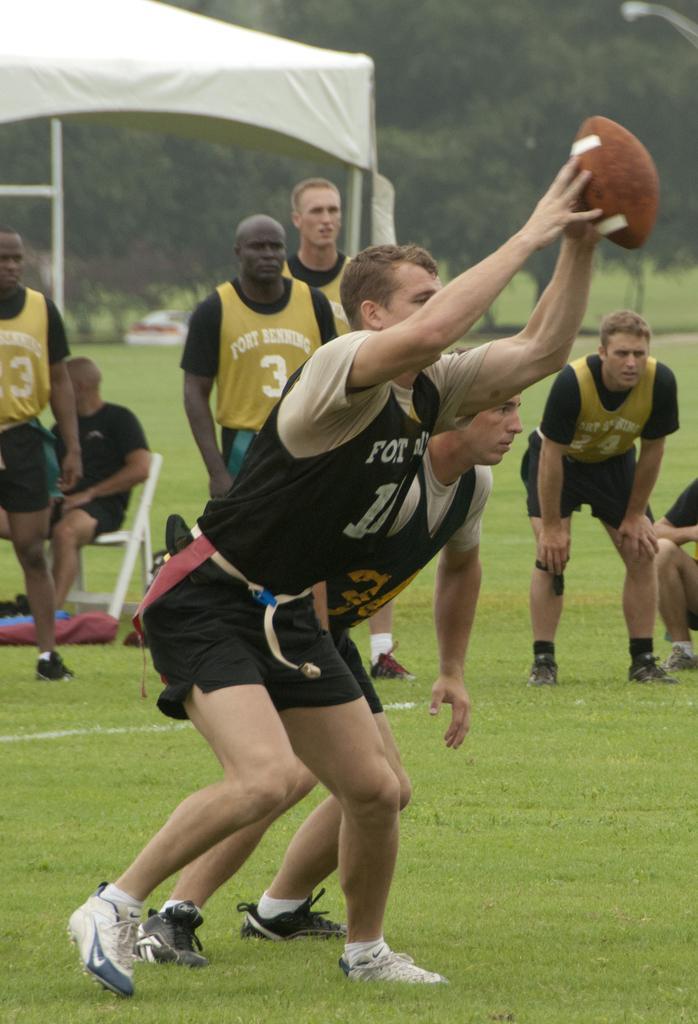Can you describe this image briefly? In this image, we can see a group of people on the grass. Here a person is a ball. On the left side of the image, a person is sitting on the white chair. Here there is a tent, rods. Background we can see trees. 